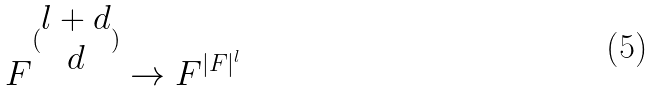<formula> <loc_0><loc_0><loc_500><loc_500>F ^ { ( \begin{matrix} l + d \\ d \end{matrix} ) } \rightarrow F ^ { | F | ^ { l } }</formula> 